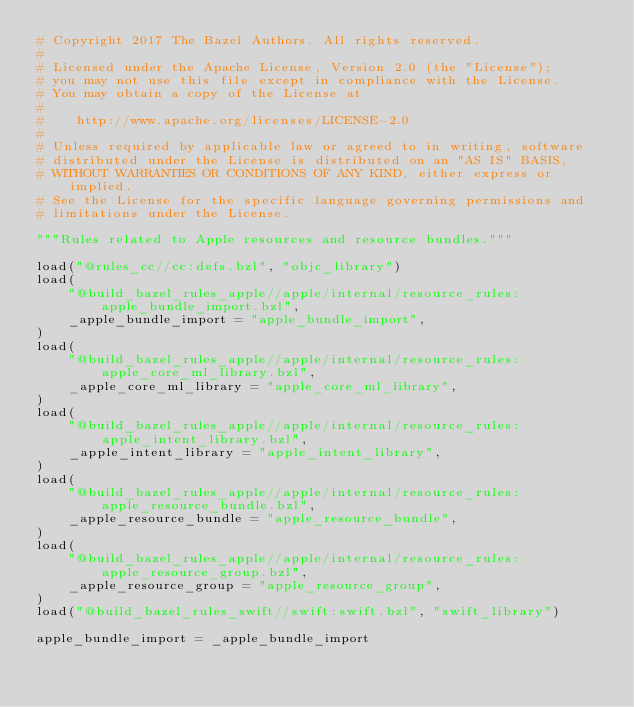<code> <loc_0><loc_0><loc_500><loc_500><_Python_># Copyright 2017 The Bazel Authors. All rights reserved.
#
# Licensed under the Apache License, Version 2.0 (the "License");
# you may not use this file except in compliance with the License.
# You may obtain a copy of the License at
#
#    http://www.apache.org/licenses/LICENSE-2.0
#
# Unless required by applicable law or agreed to in writing, software
# distributed under the License is distributed on an "AS IS" BASIS,
# WITHOUT WARRANTIES OR CONDITIONS OF ANY KIND, either express or implied.
# See the License for the specific language governing permissions and
# limitations under the License.

"""Rules related to Apple resources and resource bundles."""

load("@rules_cc//cc:defs.bzl", "objc_library")
load(
    "@build_bazel_rules_apple//apple/internal/resource_rules:apple_bundle_import.bzl",
    _apple_bundle_import = "apple_bundle_import",
)
load(
    "@build_bazel_rules_apple//apple/internal/resource_rules:apple_core_ml_library.bzl",
    _apple_core_ml_library = "apple_core_ml_library",
)
load(
    "@build_bazel_rules_apple//apple/internal/resource_rules:apple_intent_library.bzl",
    _apple_intent_library = "apple_intent_library",
)
load(
    "@build_bazel_rules_apple//apple/internal/resource_rules:apple_resource_bundle.bzl",
    _apple_resource_bundle = "apple_resource_bundle",
)
load(
    "@build_bazel_rules_apple//apple/internal/resource_rules:apple_resource_group.bzl",
    _apple_resource_group = "apple_resource_group",
)
load("@build_bazel_rules_swift//swift:swift.bzl", "swift_library")

apple_bundle_import = _apple_bundle_import</code> 